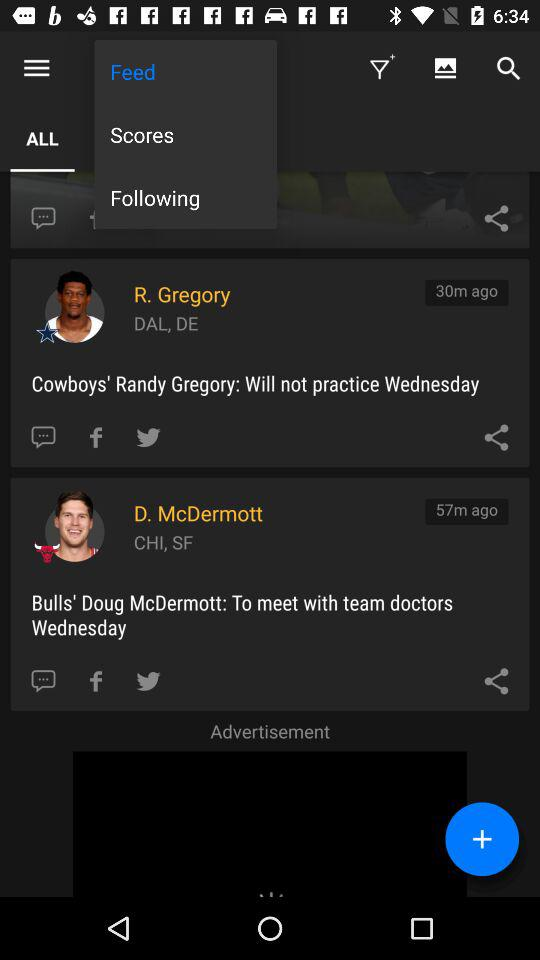When was the feed posted by R. Gregory? The feed was posted 30 minutes ago by R. Gregory. 